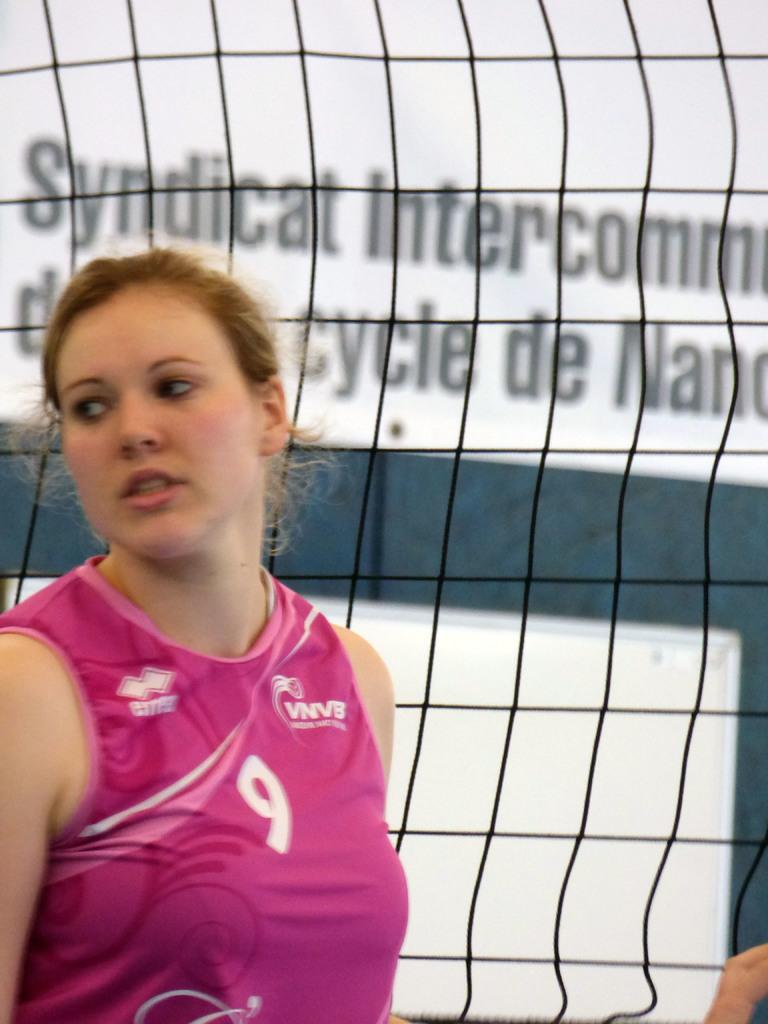<image>
Provide a brief description of the given image. A Syndicat Intercommunal athlete stands near the net. 